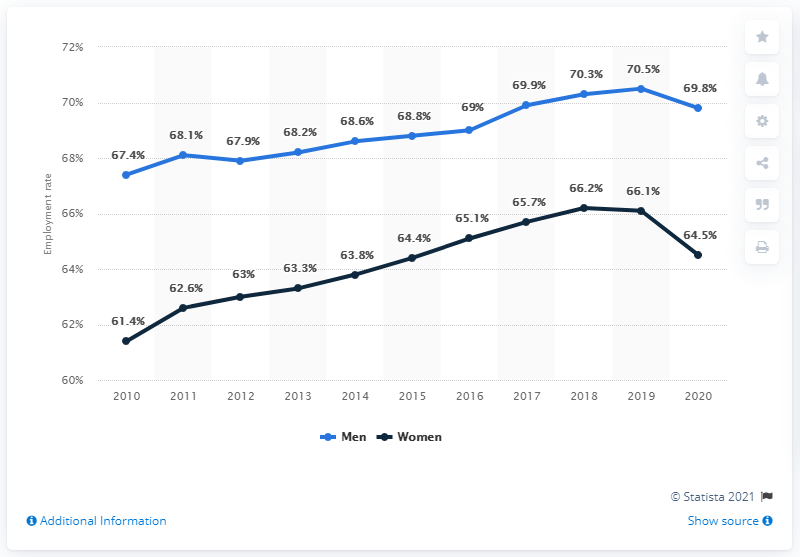Give some essential details in this illustration. The average employment rate for men in 2019-2020 was 0.7%. The employment rate for men in 2020 is 69.8%. In 2020, the employment rate for women was 64.5%. The employment rate in Sweden was 64.5% in 2010, which was the lowest rate at that time. The employment rate in Sweden in 2020 was 67.4%. 